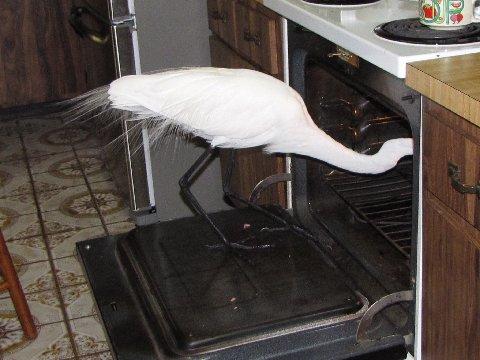Is there a dog in the kitchen?
Keep it brief. No. IS there anything weird about this?
Short answer required. Yes. What is the animal standing on?
Short answer required. Oven door. Which animal is this?
Concise answer only. Bird. 